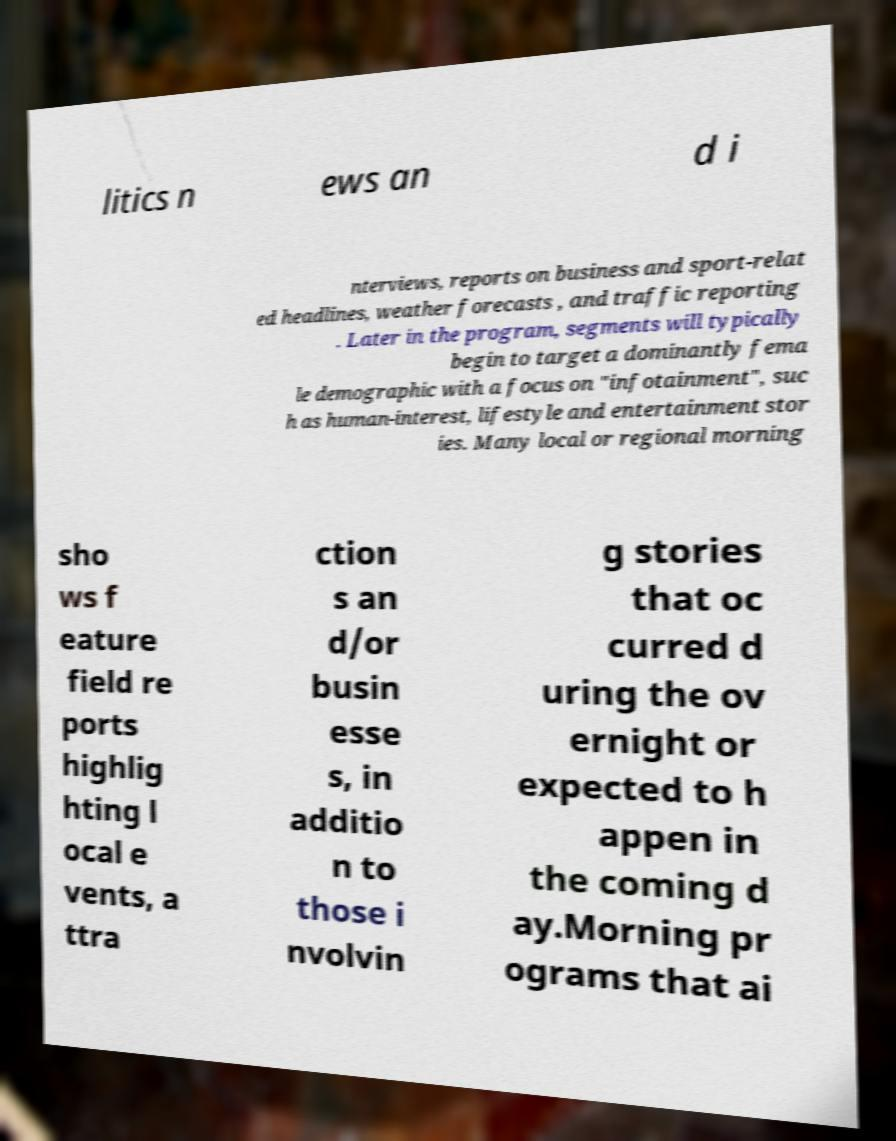Please read and relay the text visible in this image. What does it say? litics n ews an d i nterviews, reports on business and sport-relat ed headlines, weather forecasts , and traffic reporting . Later in the program, segments will typically begin to target a dominantly fema le demographic with a focus on "infotainment", suc h as human-interest, lifestyle and entertainment stor ies. Many local or regional morning sho ws f eature field re ports highlig hting l ocal e vents, a ttra ction s an d/or busin esse s, in additio n to those i nvolvin g stories that oc curred d uring the ov ernight or expected to h appen in the coming d ay.Morning pr ograms that ai 